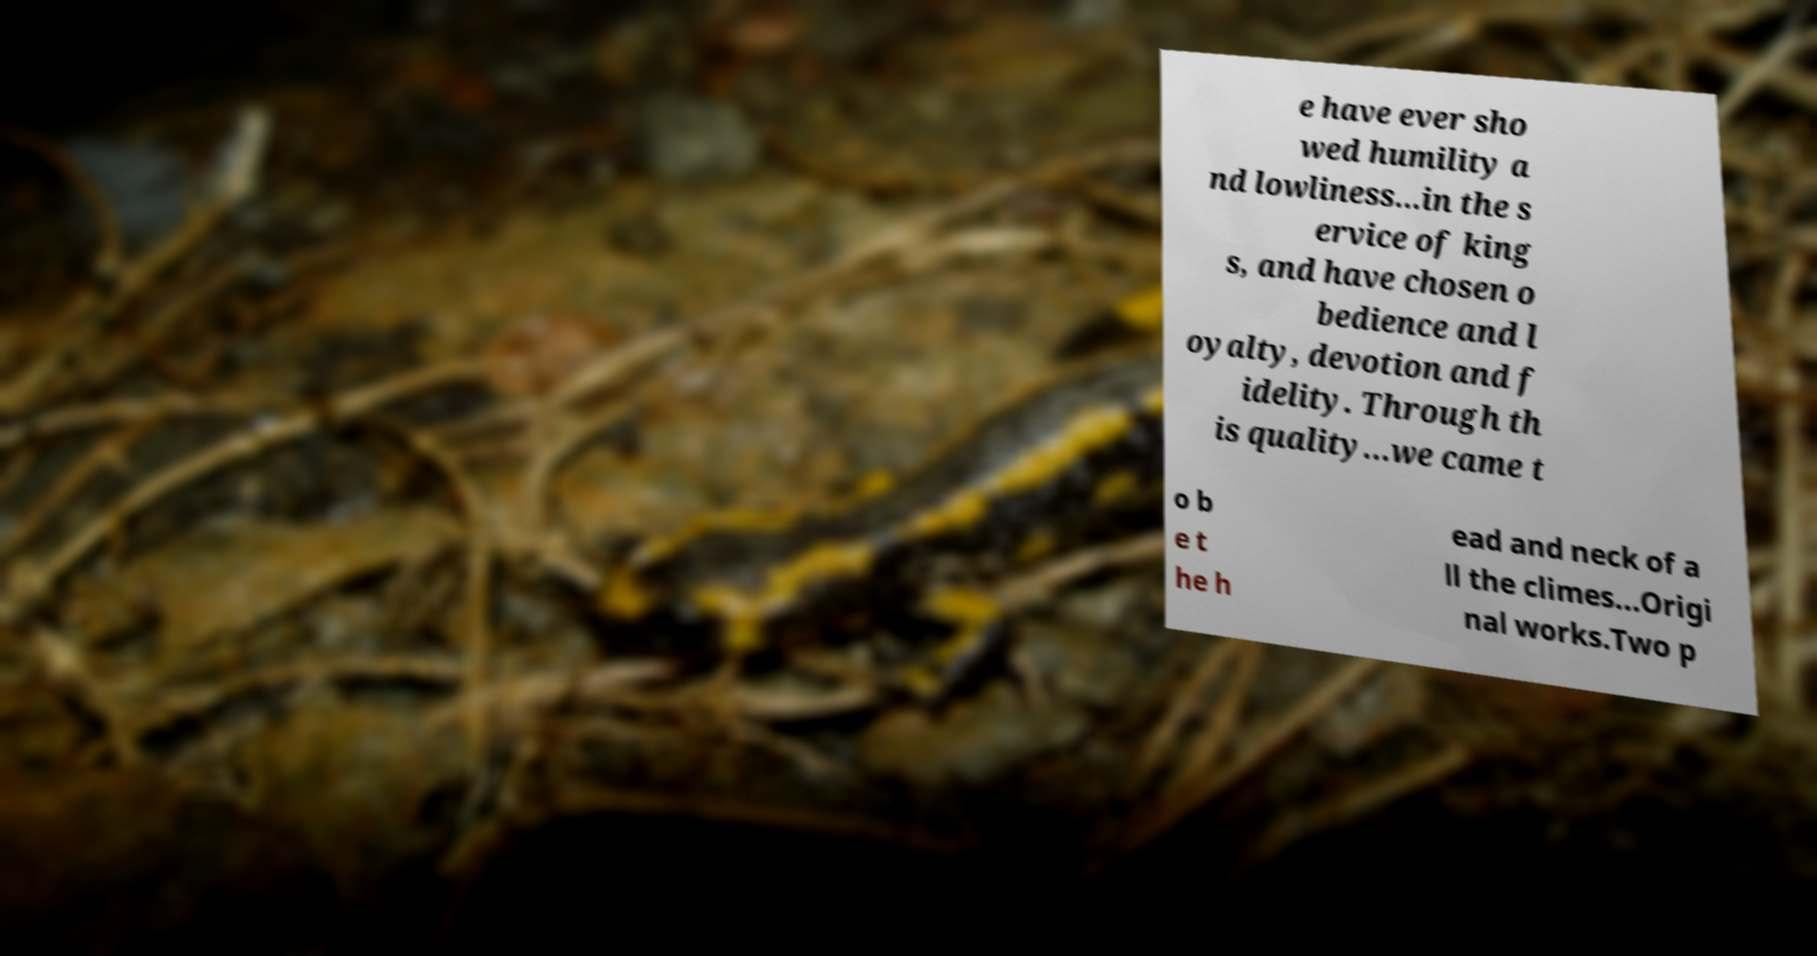Can you read and provide the text displayed in the image?This photo seems to have some interesting text. Can you extract and type it out for me? e have ever sho wed humility a nd lowliness…in the s ervice of king s, and have chosen o bedience and l oyalty, devotion and f idelity. Through th is quality…we came t o b e t he h ead and neck of a ll the climes...Origi nal works.Two p 